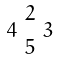Convert formula to latex. <formula><loc_0><loc_0><loc_500><loc_500>\begin{smallmatrix} & 2 & \\ 4 & & 3 \\ & 5 & \end{smallmatrix}</formula> 